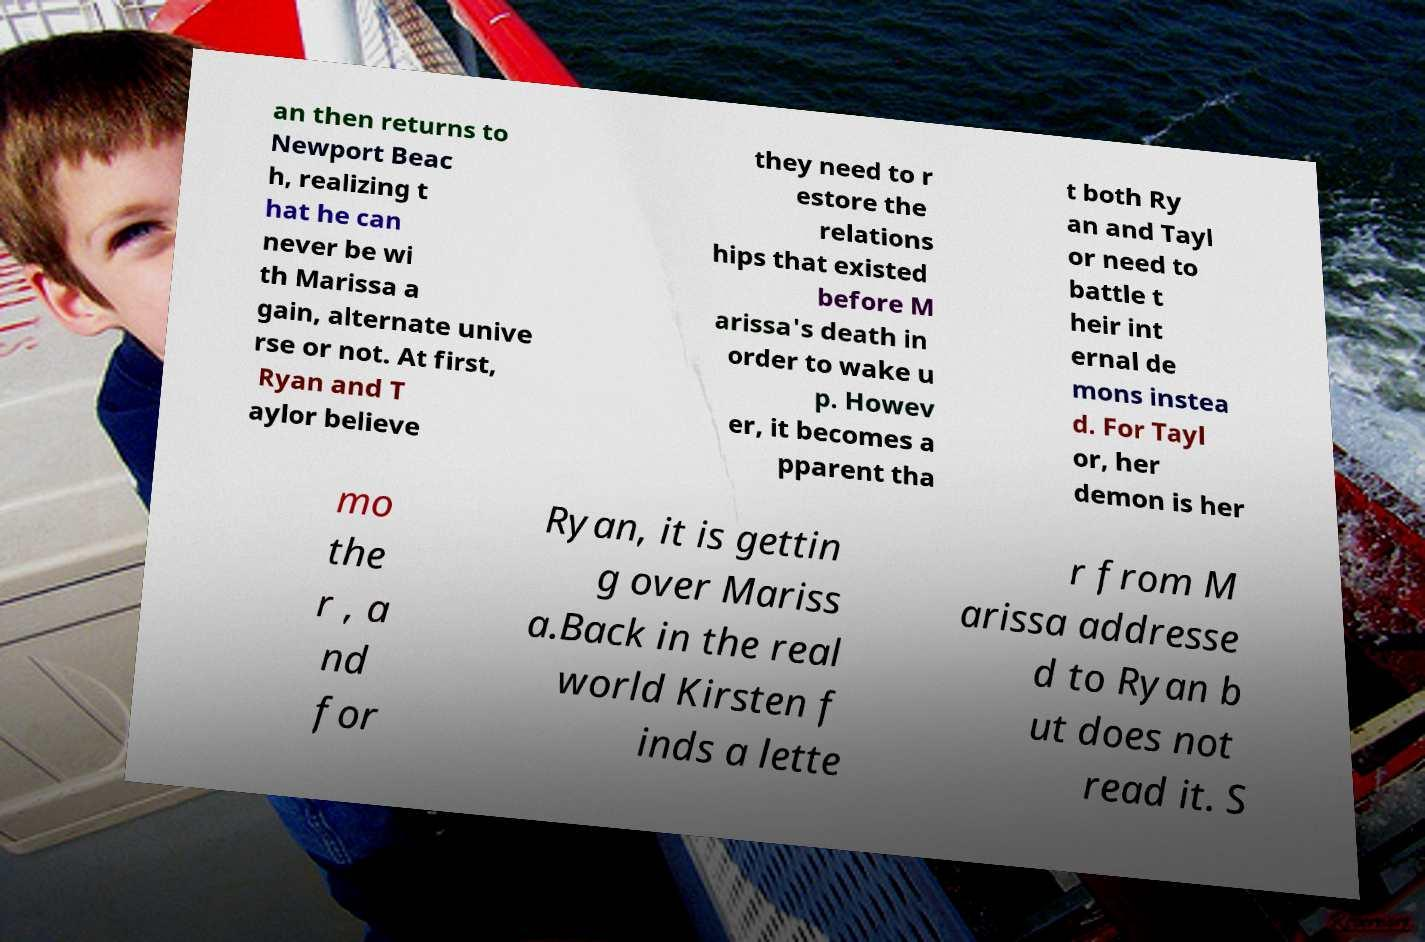Could you assist in decoding the text presented in this image and type it out clearly? an then returns to Newport Beac h, realizing t hat he can never be wi th Marissa a gain, alternate unive rse or not. At first, Ryan and T aylor believe they need to r estore the relations hips that existed before M arissa's death in order to wake u p. Howev er, it becomes a pparent tha t both Ry an and Tayl or need to battle t heir int ernal de mons instea d. For Tayl or, her demon is her mo the r , a nd for Ryan, it is gettin g over Mariss a.Back in the real world Kirsten f inds a lette r from M arissa addresse d to Ryan b ut does not read it. S 